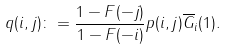<formula> <loc_0><loc_0><loc_500><loc_500>q ( i , j ) \colon = \frac { 1 - F ( - j ) } { 1 - F ( - i ) } p ( i , j ) \overline { G } _ { i } ( 1 ) .</formula> 